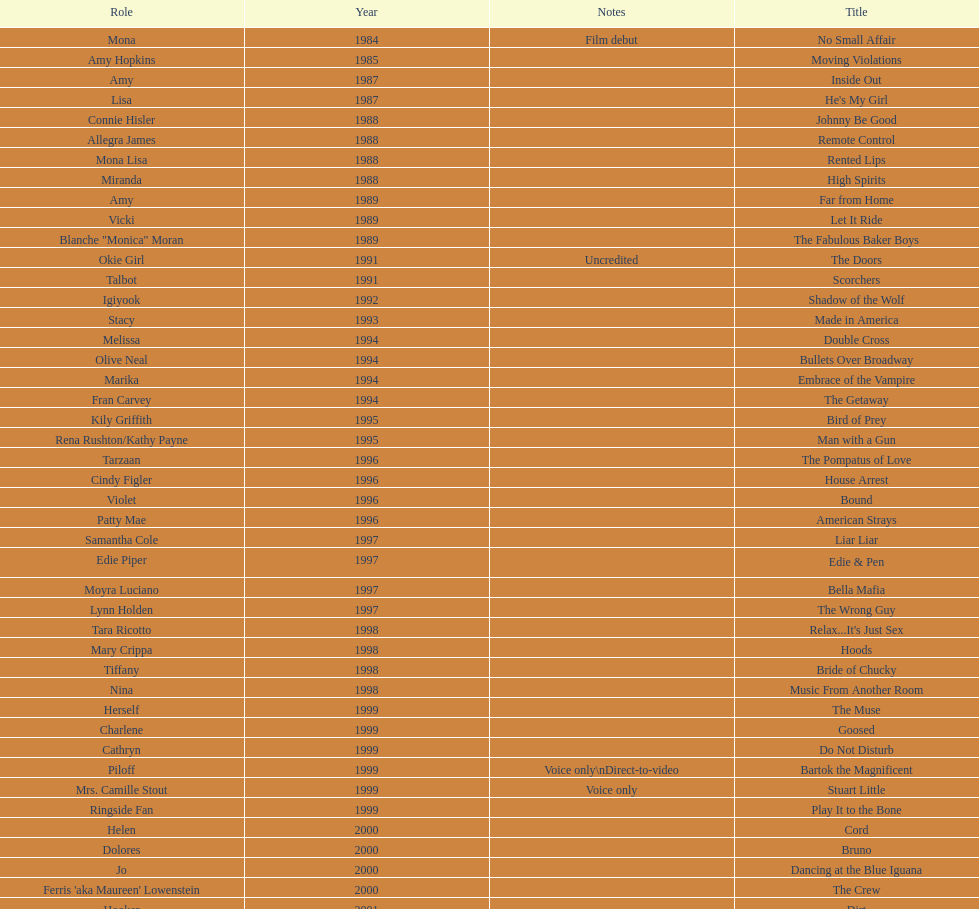Could you parse the entire table as a dict? {'header': ['Role', 'Year', 'Notes', 'Title'], 'rows': [['Mona', '1984', 'Film debut', 'No Small Affair'], ['Amy Hopkins', '1985', '', 'Moving Violations'], ['Amy', '1987', '', 'Inside Out'], ['Lisa', '1987', '', "He's My Girl"], ['Connie Hisler', '1988', '', 'Johnny Be Good'], ['Allegra James', '1988', '', 'Remote Control'], ['Mona Lisa', '1988', '', 'Rented Lips'], ['Miranda', '1988', '', 'High Spirits'], ['Amy', '1989', '', 'Far from Home'], ['Vicki', '1989', '', 'Let It Ride'], ['Blanche "Monica" Moran', '1989', '', 'The Fabulous Baker Boys'], ['Okie Girl', '1991', 'Uncredited', 'The Doors'], ['Talbot', '1991', '', 'Scorchers'], ['Igiyook', '1992', '', 'Shadow of the Wolf'], ['Stacy', '1993', '', 'Made in America'], ['Melissa', '1994', '', 'Double Cross'], ['Olive Neal', '1994', '', 'Bullets Over Broadway'], ['Marika', '1994', '', 'Embrace of the Vampire'], ['Fran Carvey', '1994', '', 'The Getaway'], ['Kily Griffith', '1995', '', 'Bird of Prey'], ['Rena Rushton/Kathy Payne', '1995', '', 'Man with a Gun'], ['Tarzaan', '1996', '', 'The Pompatus of Love'], ['Cindy Figler', '1996', '', 'House Arrest'], ['Violet', '1996', '', 'Bound'], ['Patty Mae', '1996', '', 'American Strays'], ['Samantha Cole', '1997', '', 'Liar Liar'], ['Edie Piper', '1997', '', 'Edie & Pen'], ['Moyra Luciano', '1997', '', 'Bella Mafia'], ['Lynn Holden', '1997', '', 'The Wrong Guy'], ['Tara Ricotto', '1998', '', "Relax...It's Just Sex"], ['Mary Crippa', '1998', '', 'Hoods'], ['Tiffany', '1998', '', 'Bride of Chucky'], ['Nina', '1998', '', 'Music From Another Room'], ['Herself', '1999', '', 'The Muse'], ['Charlene', '1999', '', 'Goosed'], ['Cathryn', '1999', '', 'Do Not Disturb'], ['Piloff', '1999', 'Voice only\\nDirect-to-video', 'Bartok the Magnificent'], ['Mrs. Camille Stout', '1999', 'Voice only', 'Stuart Little'], ['Ringside Fan', '1999', '', 'Play It to the Bone'], ['Helen', '2000', '', 'Cord'], ['Dolores', '2000', '', 'Bruno'], ['Jo', '2000', '', 'Dancing at the Blue Iguana'], ["Ferris 'aka Maureen' Lowenstein", '2000', '', 'The Crew'], ['Hooker', '2001', '', 'Dirt'], ['Ginger Quail', '2001', '', 'Fast Sofa'], ['Celia Mae', '2001', 'Voice only', 'Monsters, Inc.'], ['Dot', '2001', '', 'Ball in the House'], ['Louella Parsons', '2001', '', "The Cat's Meow"], ['Gillian Stevens', '2003', '', 'Hollywood North'], ['Madame Leota', '2003', '', 'The Haunted Mansion'], ['Edna', '2003', '', 'Happy End'], ['Donna Cherry', '2003', '', 'Jericho Mansions'], ['Carole', '2004', '', 'Second Best'], ['Elyse Steinberg', '2004', '', 'Perfect Opposites'], ['Grace', '2004', 'Voice only', 'Home on the Range'], ['Sebeva', '2004', '', 'El Padrino'], ['Nurse Alice', '2004', '', 'Saint Ralph'], ['Alma Kerns', '2004', '', 'Love on the Side'], ['Tiffany/Herself', '2004', '', 'Seed of Chucky'], ['Dolores Pennington', '2005', '', "Bailey's Billion$"], ['Miss De La Croix', '2005', 'Voice only', "Lil' Pimp"], ["Dr. O'Shannon", '2005', '', 'The Civilization of Maxwell Bright'], ['Queen Gunhilda', '2005', '', 'Tideland'], ['Herself', '2006', '', 'The Poker Movie'], ['', '2007', '', 'Intervention'], ["Karen 'Razor' Jones", '2008', '', 'Deal'], ['Miss Perry', '2008', '', 'The Caretaker'], ['Melinda', '2008', '', 'Bart Got a Room'], ["Salome 'Sally' Marsh", '2008', '', 'Inconceivable'], ['Mrs. Rundell', '2009', '', 'An American Girl: Chrissa Stands Strong'], ['', '2009', '', 'Imps'], ['Herself', '2009', '', 'Made in Romania'], ['Mrs. Landdeck', '2009', '', 'Empire of Silver'], ['Amber', '2010', '', 'The Making of Plus One'], ['Ms. Stewart', '2010', '', 'The Secret Lives of Dorks'], ['Erika', '2012', '', '30 Beats'], ['Tiffany Ray', '2013', 'Cameo, Direct-to-video', 'Curse of Chucky']]} Which year had the most credits? 2004. 